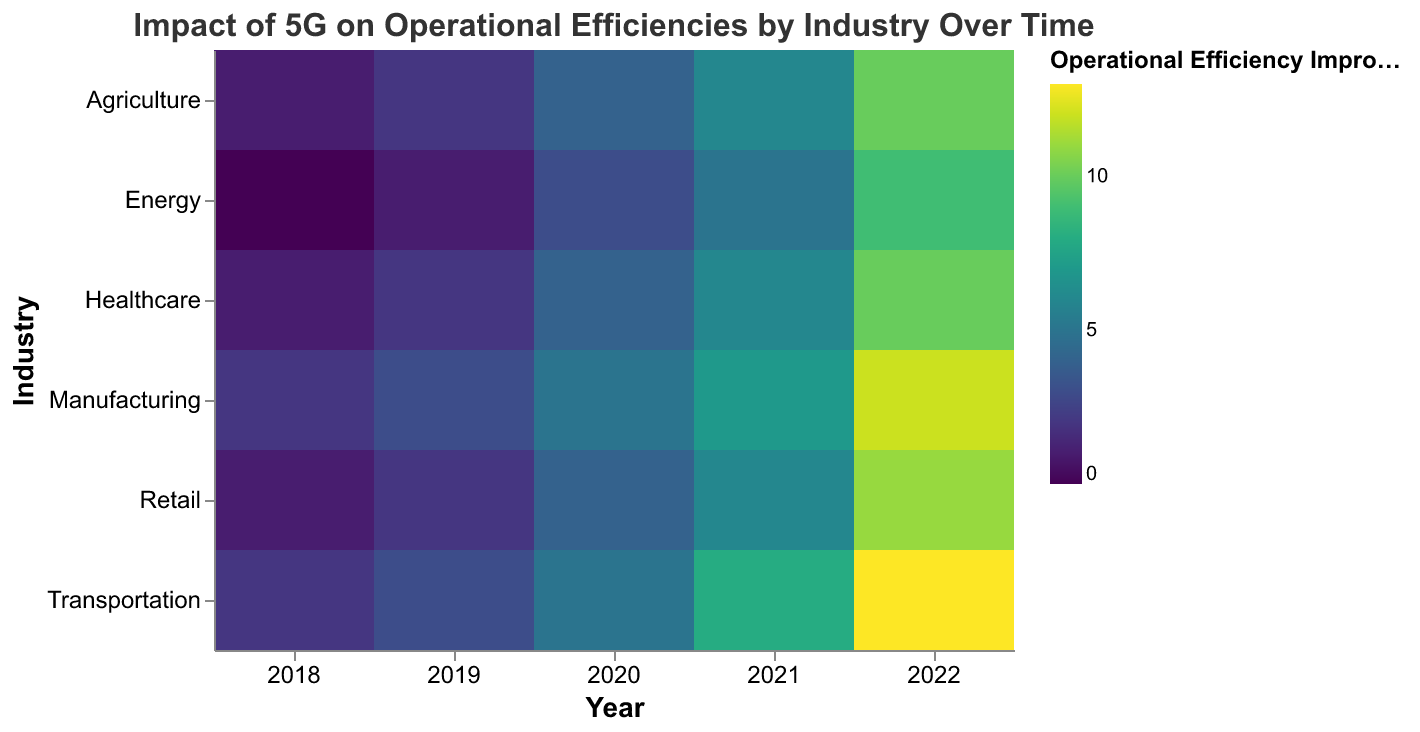What is the title of the heatmap? The title is displayed at the top center of the heatmap. It reads "Impact of 5G on Operational Efficiencies by Industry Over Time" in a 16-point Arial font.
Answer: Impact of 5G on Operational Efficiencies by Industry Over Time Which industry shows the highest operational efficiency improvement in 2022? Looking at the data for 2022 across all industries, Transportation has the highest operational efficiency improvement with a value of 13%.
Answer: Transportation What range of colors is used to indicate the operational efficiency improvement? The heatmap uses a color scale based on the viridis color scheme. This scale ranges from dark purple (for lower values) to yellow-green (for higher values).
Answer: Dark purple to yellow-green Which years are represented on the X-axis? The X-axis shows the years in chronological order. These years are: 2018, 2019, 2020, 2021, and 2022.
Answer: 2018, 2019, 2020, 2021, 2022 How does the operational efficiency improvement of Healthcare in 2020 compare to that in 2018? In 2020, Healthcare shows an operational efficiency improvement value of 4%, while in 2018, it is 1%. The improvement in 2020 is therefore greater by 3 percentage points compared to 2018.
Answer: 3 percentage points On average, how much did operational efficiency improve across all industries in 2021? To find the average improvement for 2021, sum the improvement percentages of all industries and divide by the number of industries: (7 + 6 + 6 + 8 + 5 + 6) / 6 = 38 / 6 = 6.33%.
Answer: 6.33% Which industry had the least improvement in operational efficiency over the entire period? Analyzing the data, Energy started with 0% in 2018 and reached 9% in 2022, which is the least improvement overall compared to other industries.
Answer: Energy What is the total operational efficiency improvement for Manufacturing from 2018 to 2022? Sum up the improvement values for Manufacturing over the given years: 2 (2018) + 3 (2019) + 5 (2020) + 7 (2021) + 12 (2022) = 29%.
Answer: 29% Which two industries showed the same operational efficiency improvement in 2021? In 2021, Healthcare and Retail both show an operational efficiency improvement of 6%.
Answer: Healthcare and Retail How does the operational efficiency improvement trend for Agriculture compare between 2018 and 2022? The operational efficiency improvement for Agriculture increases from 1% in 2018 to 10% in 2022, showing a positive and increasing trend over the years.
Answer: Increasing trend, from 1% to 10% 